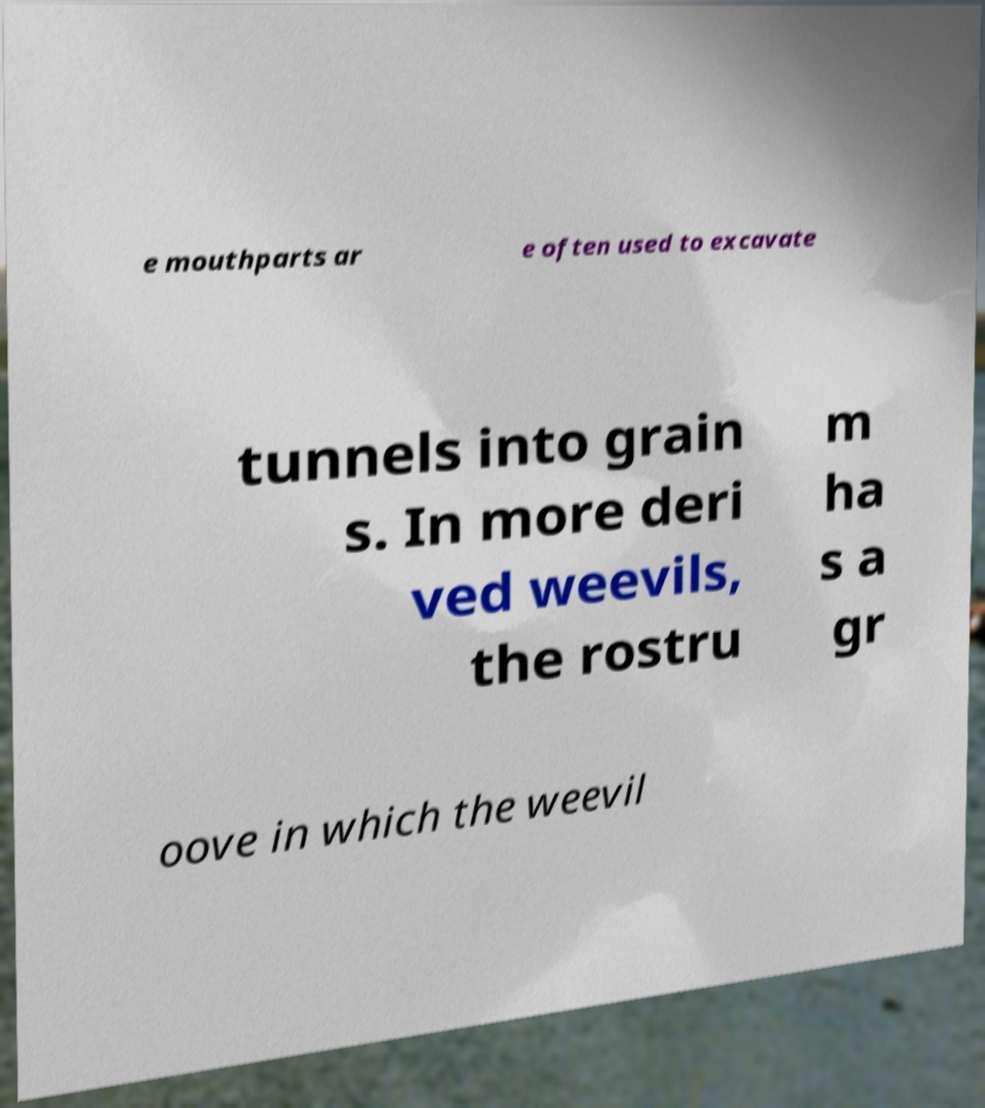For documentation purposes, I need the text within this image transcribed. Could you provide that? e mouthparts ar e often used to excavate tunnels into grain s. In more deri ved weevils, the rostru m ha s a gr oove in which the weevil 